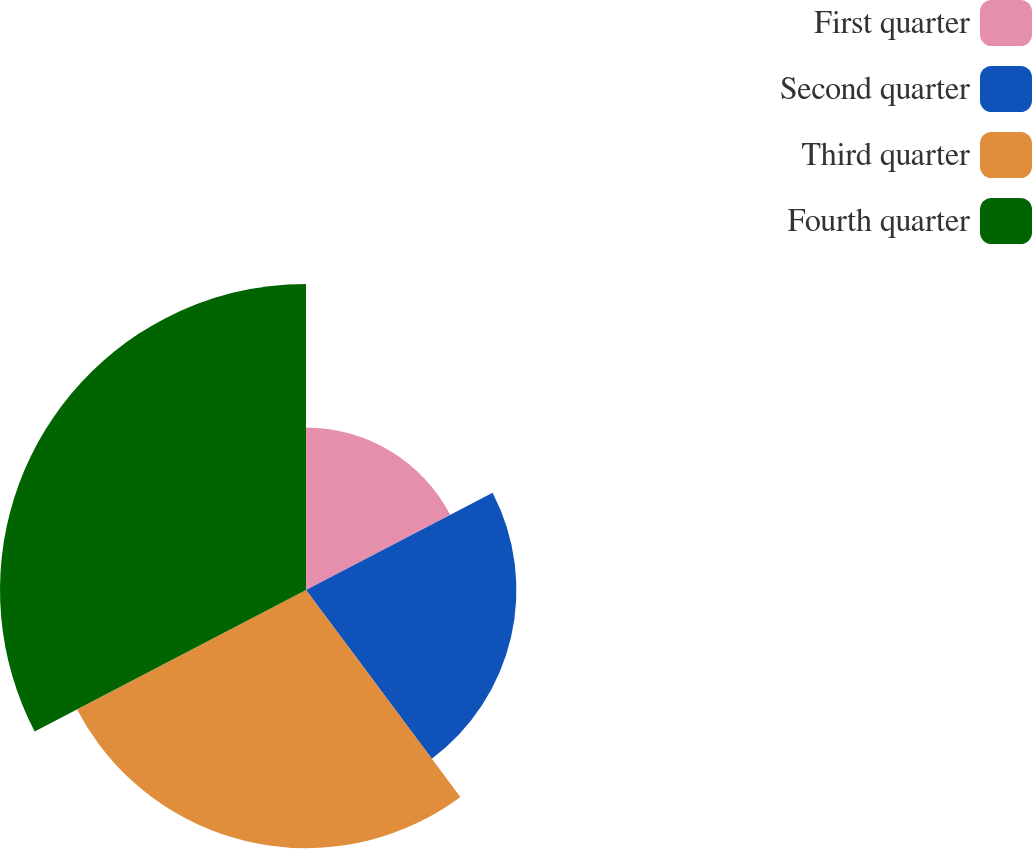<chart> <loc_0><loc_0><loc_500><loc_500><pie_chart><fcel>First quarter<fcel>Second quarter<fcel>Third quarter<fcel>Fourth quarter<nl><fcel>17.35%<fcel>22.45%<fcel>27.55%<fcel>32.65%<nl></chart> 